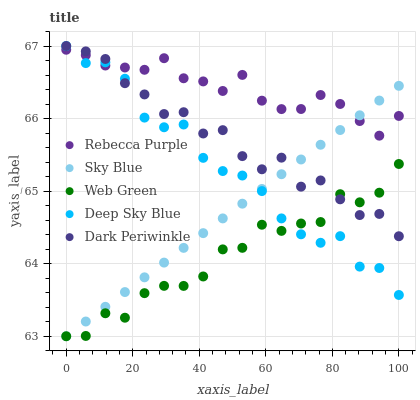Does Web Green have the minimum area under the curve?
Answer yes or no. Yes. Does Rebecca Purple have the maximum area under the curve?
Answer yes or no. Yes. Does Dark Periwinkle have the minimum area under the curve?
Answer yes or no. No. Does Dark Periwinkle have the maximum area under the curve?
Answer yes or no. No. Is Sky Blue the smoothest?
Answer yes or no. Yes. Is Web Green the roughest?
Answer yes or no. Yes. Is Dark Periwinkle the smoothest?
Answer yes or no. No. Is Dark Periwinkle the roughest?
Answer yes or no. No. Does Sky Blue have the lowest value?
Answer yes or no. Yes. Does Dark Periwinkle have the lowest value?
Answer yes or no. No. Does Deep Sky Blue have the highest value?
Answer yes or no. Yes. Does Rebecca Purple have the highest value?
Answer yes or no. No. Is Web Green less than Rebecca Purple?
Answer yes or no. Yes. Is Rebecca Purple greater than Web Green?
Answer yes or no. Yes. Does Rebecca Purple intersect Deep Sky Blue?
Answer yes or no. Yes. Is Rebecca Purple less than Deep Sky Blue?
Answer yes or no. No. Is Rebecca Purple greater than Deep Sky Blue?
Answer yes or no. No. Does Web Green intersect Rebecca Purple?
Answer yes or no. No. 